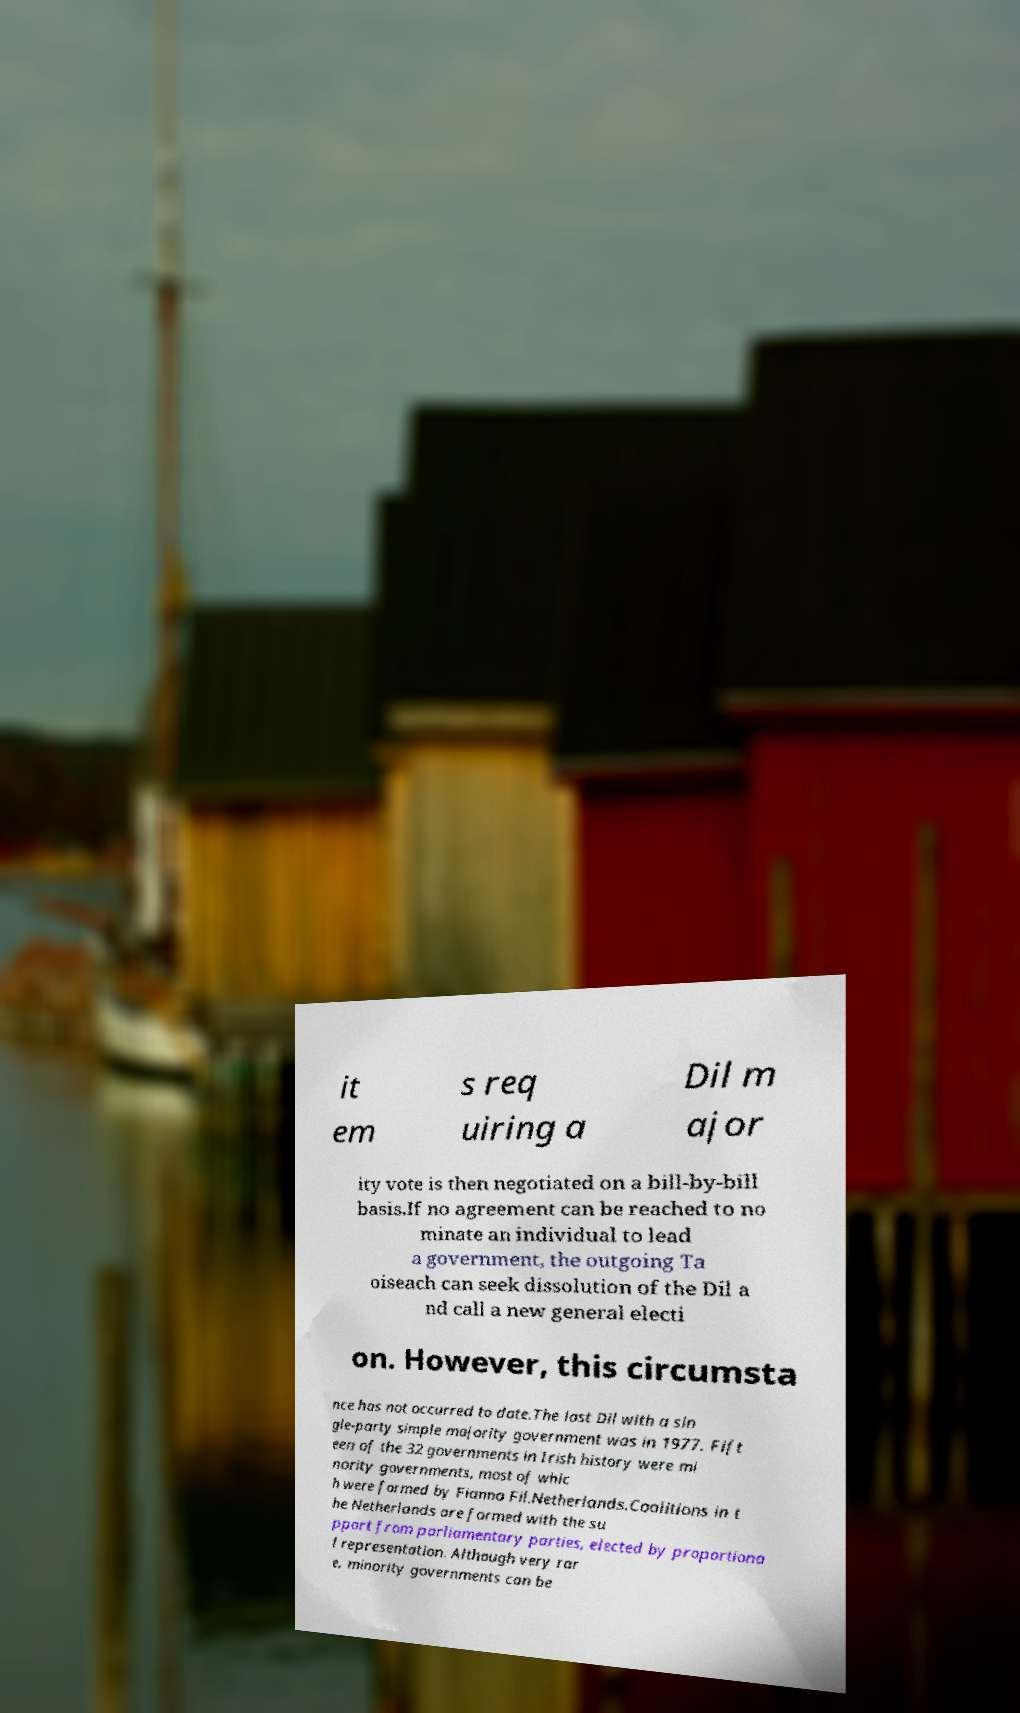Could you assist in decoding the text presented in this image and type it out clearly? it em s req uiring a Dil m ajor ity vote is then negotiated on a bill-by-bill basis.If no agreement can be reached to no minate an individual to lead a government, the outgoing Ta oiseach can seek dissolution of the Dil a nd call a new general electi on. However, this circumsta nce has not occurred to date.The last Dil with a sin gle-party simple majority government was in 1977. Fift een of the 32 governments in Irish history were mi nority governments, most of whic h were formed by Fianna Fil.Netherlands.Coalitions in t he Netherlands are formed with the su pport from parliamentary parties, elected by proportiona l representation. Although very rar e, minority governments can be 